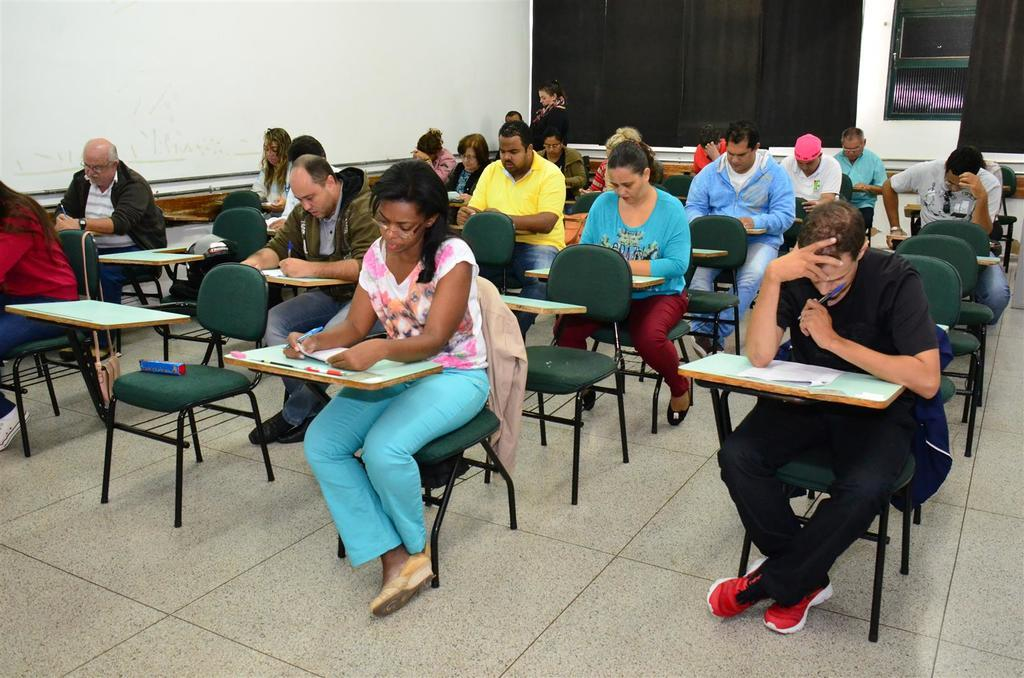What is happening in the image involving a group of people? The people in the image are writing an examination. Where is the examination taking place? The examination is taking place in a room. What might be used by the people to write their answers? The people might be using pens or pencils to write their answers. What type of animals can be seen in the zoo in the image? There is no zoo present in the image; it features a group of people writing an examination in a room. 